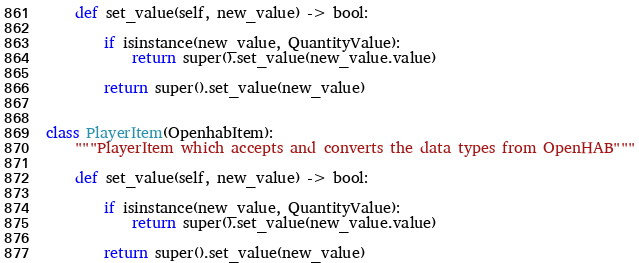<code> <loc_0><loc_0><loc_500><loc_500><_Python_>
    def set_value(self, new_value) -> bool:

        if isinstance(new_value, QuantityValue):
            return super().set_value(new_value.value)

        return super().set_value(new_value)


class PlayerItem(OpenhabItem):
    """PlayerItem which accepts and converts the data types from OpenHAB"""

    def set_value(self, new_value) -> bool:

        if isinstance(new_value, QuantityValue):
            return super().set_value(new_value.value)

        return super().set_value(new_value)
</code> 